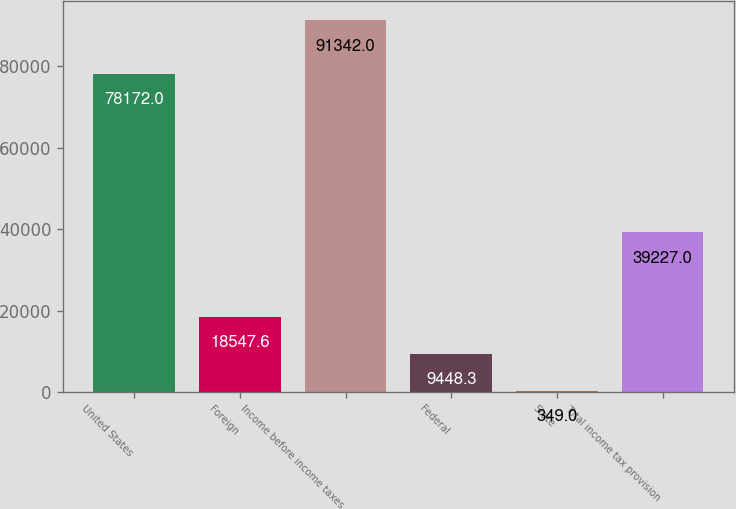Convert chart to OTSL. <chart><loc_0><loc_0><loc_500><loc_500><bar_chart><fcel>United States<fcel>Foreign<fcel>Income before income taxes<fcel>Federal<fcel>State<fcel>Total income tax provision<nl><fcel>78172<fcel>18547.6<fcel>91342<fcel>9448.3<fcel>349<fcel>39227<nl></chart> 